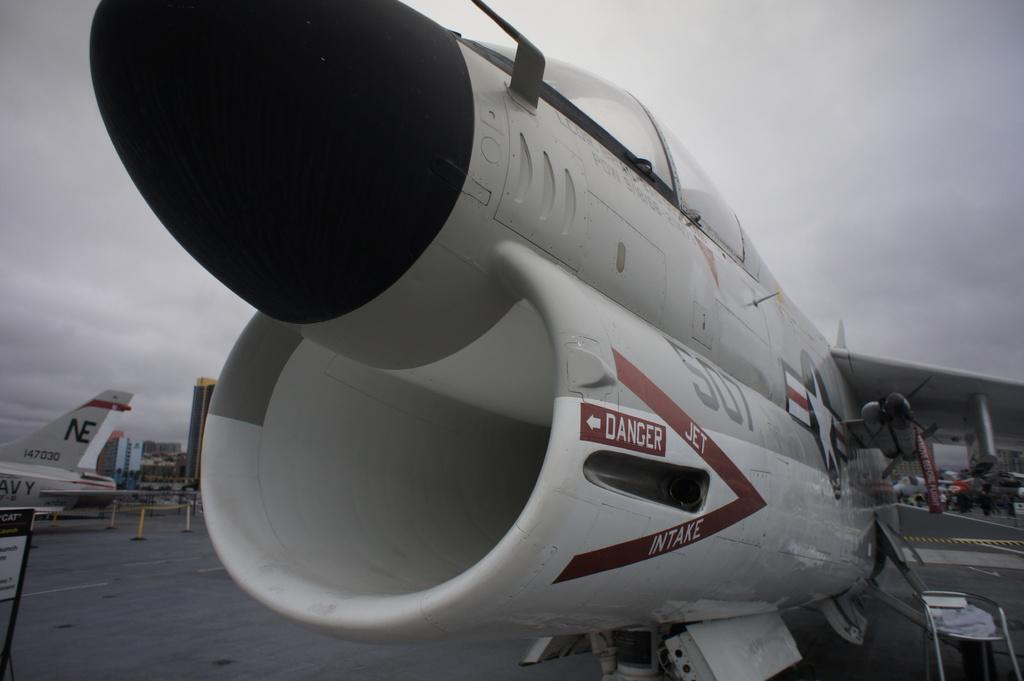<image>
Present a compact description of the photo's key features. Up close of an airplane that hs a sign that says Danger on it. 